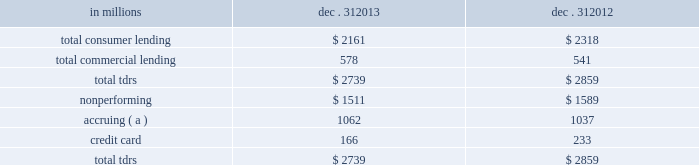Troubled debt restructurings ( tdrs ) a tdr is a loan whose terms have been restructured in a manner that grants a concession to a borrower experiencing financial difficulties .
Tdrs result from our loss mitigation activities , and include rate reductions , principal forgiveness , postponement/reduction of scheduled amortization , and extensions , which are intended to minimize economic loss and to avoid foreclosure or repossession of collateral .
Additionally , tdrs also result from borrowers that have been discharged from personal liability through chapter 7 bankruptcy and have not formally reaffirmed their loan obligations to pnc .
In those situations where principal is forgiven , the amount of such principal forgiveness is immediately charged off .
Some tdrs may not ultimately result in the full collection of principal and interest , as restructured , and result in potential incremental losses .
These potential incremental losses have been factored into our overall alll estimate .
The level of any subsequent defaults will likely be affected by future economic conditions .
Once a loan becomes a tdr , it will continue to be reported as a tdr until it is ultimately repaid in full , the collateral is foreclosed upon , or it is fully charged off .
We held specific reserves in the alll of $ .5 billion and $ .6 billion at december 31 , 2013 and december 31 , 2012 , respectively , for the total tdr portfolio .
Table 70 : summary of troubled debt restructurings in millions dec .
31 dec .
31 .
( a ) accruing loans have demonstrated a period of at least six months of performance under the restructured terms and are excluded from nonperforming loans .
Loans where borrowers have been discharged from personal liability through chapter 7 bankruptcy and have not formally reaffirmed their loan obligations to pnc are not returned to accrual status .
Table 71 quantifies the number of loans that were classified as tdrs as well as the change in the recorded investments as a result of the tdr classification during 2013 , 2012 and 2011 .
Additionally , the table provides information about the types of tdr concessions .
The principal forgiveness tdr category includes principal forgiveness and accrued interest forgiveness .
These types of tdrs result in a write down of the recorded investment and a charge-off if such action has not already taken place .
The rate reduction tdr category includes reduced interest rate and interest deferral .
The tdrs within this category would result in reductions to future interest income .
The other tdr category primarily includes consumer borrowers that have been discharged from personal liability through chapter 7 bankruptcy and have not formally reaffirmed their loan obligations to pnc , as well as postponement/reduction of scheduled amortization and contractual extensions for both consumer and commercial borrowers .
In some cases , there have been multiple concessions granted on one loan .
This is most common within the commercial loan portfolio .
When there have been multiple concessions granted in the commercial loan portfolio , the principal forgiveness tdr was prioritized for purposes of determining the inclusion in the table below .
For example , if there is principal forgiveness in conjunction with lower interest rate and postponement of amortization , the type of concession will be reported as principal forgiveness .
Second in priority would be rate reduction .
For example , if there is an interest rate reduction in conjunction with postponement of amortization , the type of concession will be reported as a rate reduction .
In the event that multiple concessions are granted on a consumer loan , concessions resulting from discharge from personal liability through chapter 7 bankruptcy without formal affirmation of the loan obligations to pnc would be prioritized and included in the other type of concession in the table below .
After that , consumer loan concessions would follow the previously discussed priority of concessions for the commercial loan portfolio .
140 the pnc financial services group , inc .
2013 form 10-k .
What was the change in the balance in millions of nonperforming loans from 2012 to 2013? 
Computations: (1589 - 1511)
Answer: 78.0. 